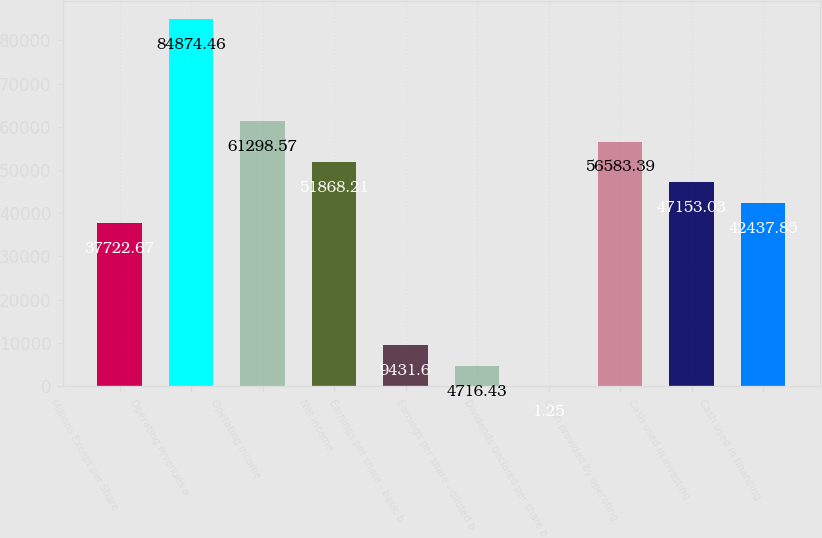<chart> <loc_0><loc_0><loc_500><loc_500><bar_chart><fcel>Millions Except per Share<fcel>Operating revenues a<fcel>Operating income<fcel>Net income<fcel>Earnings per share - basic b<fcel>Earnings per share - diluted b<fcel>Dividends declared per share b<fcel>Cash provided by operating<fcel>Cash used in investing<fcel>Cash used in financing<nl><fcel>37722.7<fcel>84874.5<fcel>61298.6<fcel>51868.2<fcel>9431.6<fcel>4716.43<fcel>1.25<fcel>56583.4<fcel>47153<fcel>42437.8<nl></chart> 